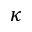Convert formula to latex. <formula><loc_0><loc_0><loc_500><loc_500>\kappa</formula> 